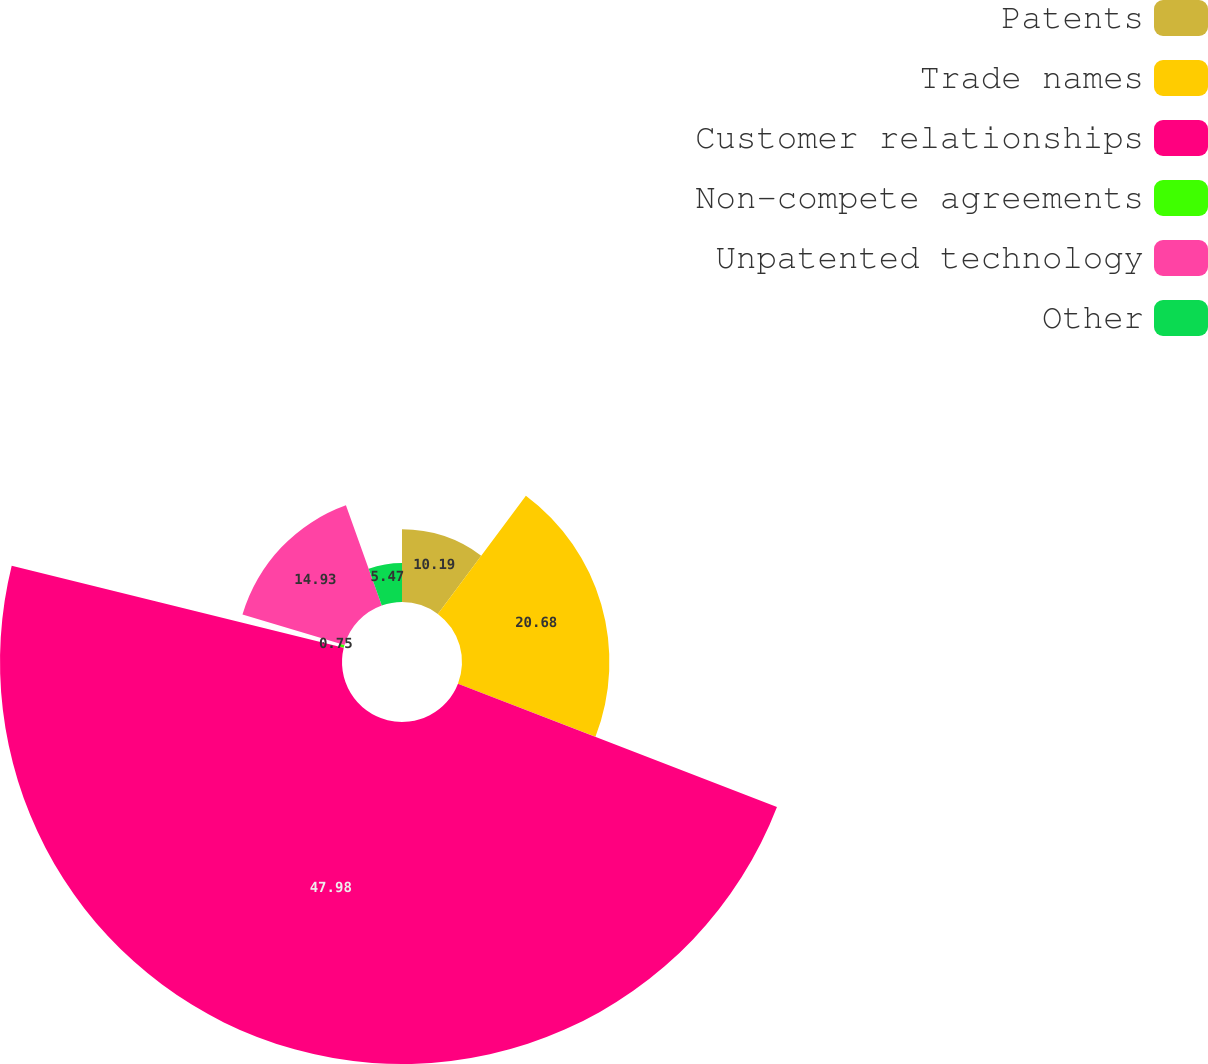Convert chart. <chart><loc_0><loc_0><loc_500><loc_500><pie_chart><fcel>Patents<fcel>Trade names<fcel>Customer relationships<fcel>Non-compete agreements<fcel>Unpatented technology<fcel>Other<nl><fcel>10.19%<fcel>20.68%<fcel>47.98%<fcel>0.75%<fcel>14.93%<fcel>5.47%<nl></chart> 